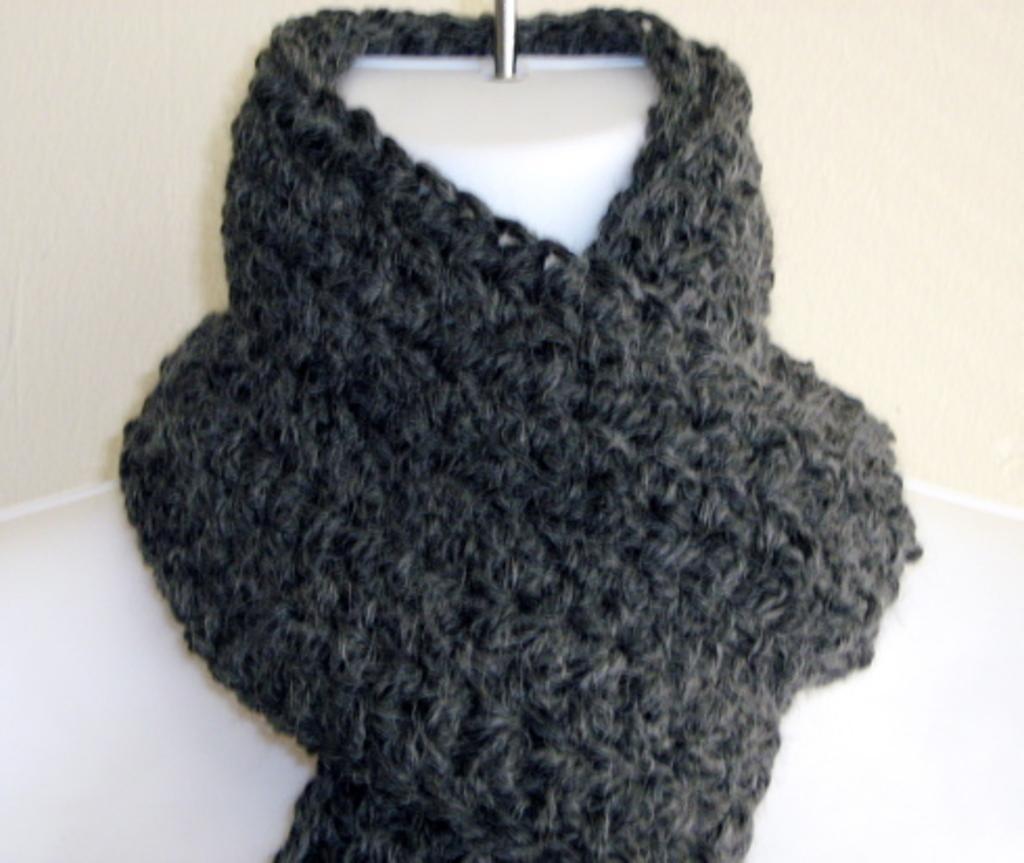How would you summarize this image in a sentence or two? In this picture there is a scarf placed on a mannequin. 